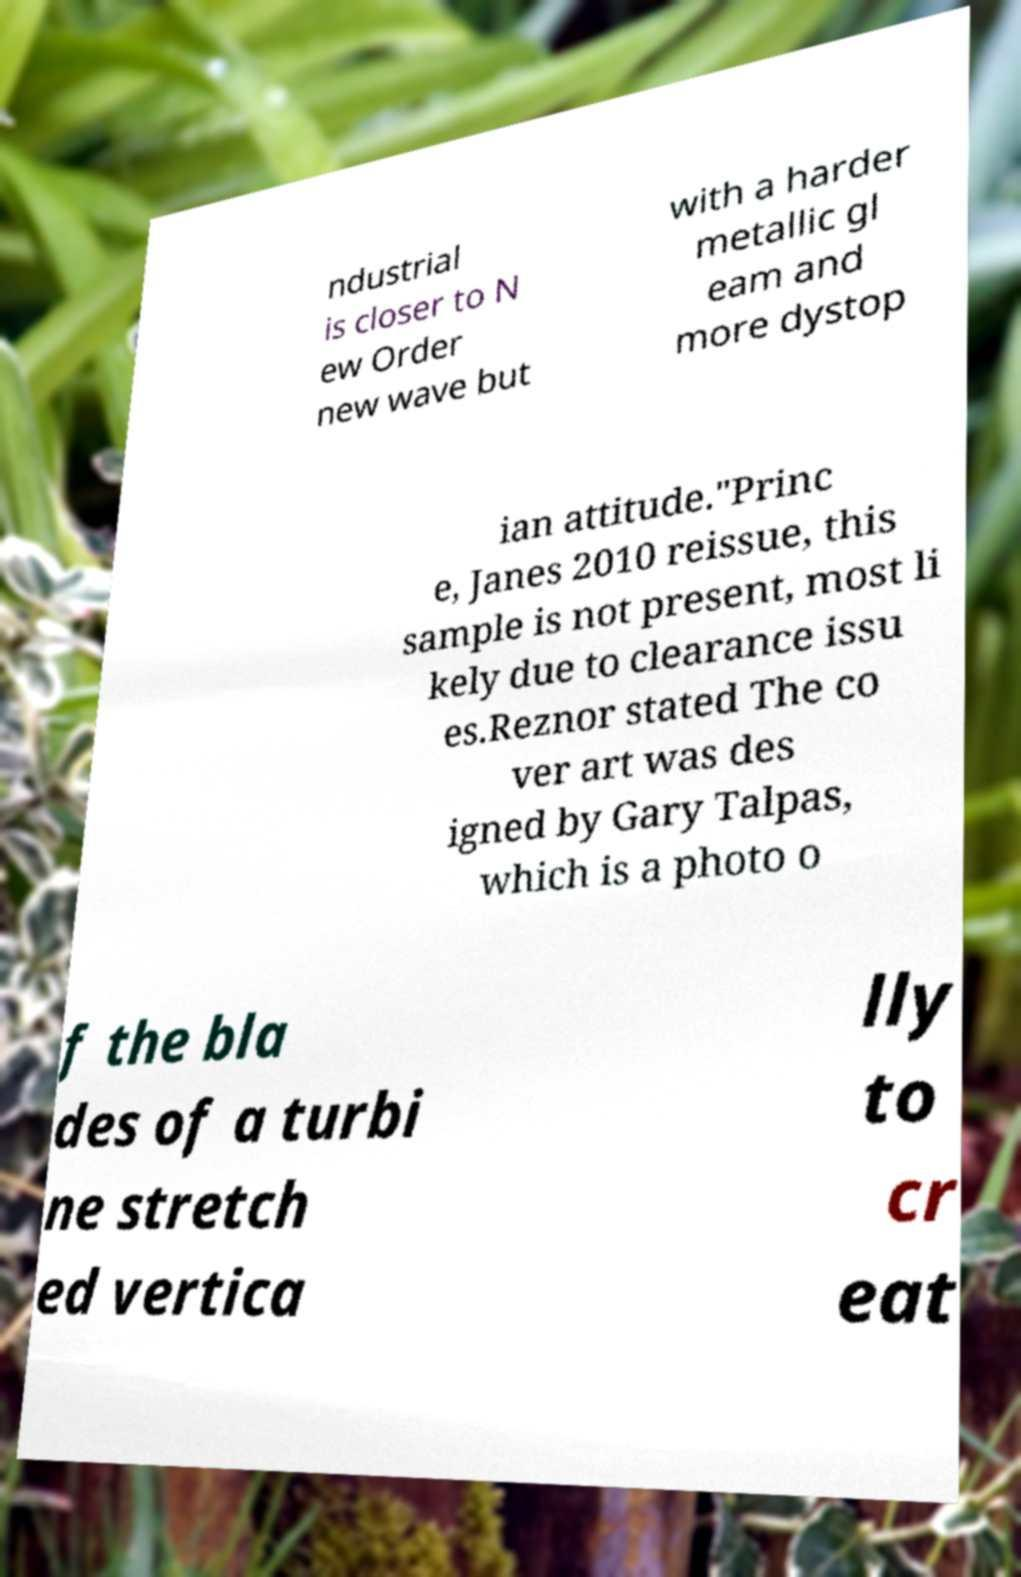Can you read and provide the text displayed in the image?This photo seems to have some interesting text. Can you extract and type it out for me? ndustrial is closer to N ew Order new wave but with a harder metallic gl eam and more dystop ian attitude."Princ e, Janes 2010 reissue, this sample is not present, most li kely due to clearance issu es.Reznor stated The co ver art was des igned by Gary Talpas, which is a photo o f the bla des of a turbi ne stretch ed vertica lly to cr eat 